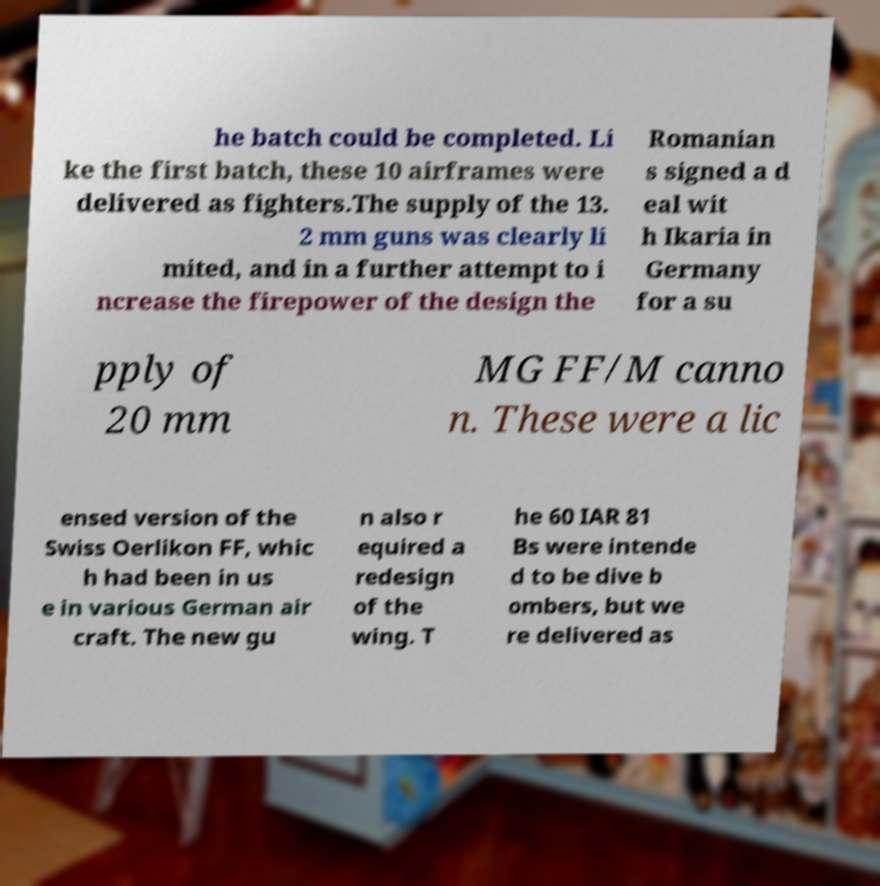There's text embedded in this image that I need extracted. Can you transcribe it verbatim? he batch could be completed. Li ke the first batch, these 10 airframes were delivered as fighters.The supply of the 13. 2 mm guns was clearly li mited, and in a further attempt to i ncrease the firepower of the design the Romanian s signed a d eal wit h Ikaria in Germany for a su pply of 20 mm MG FF/M canno n. These were a lic ensed version of the Swiss Oerlikon FF, whic h had been in us e in various German air craft. The new gu n also r equired a redesign of the wing. T he 60 IAR 81 Bs were intende d to be dive b ombers, but we re delivered as 